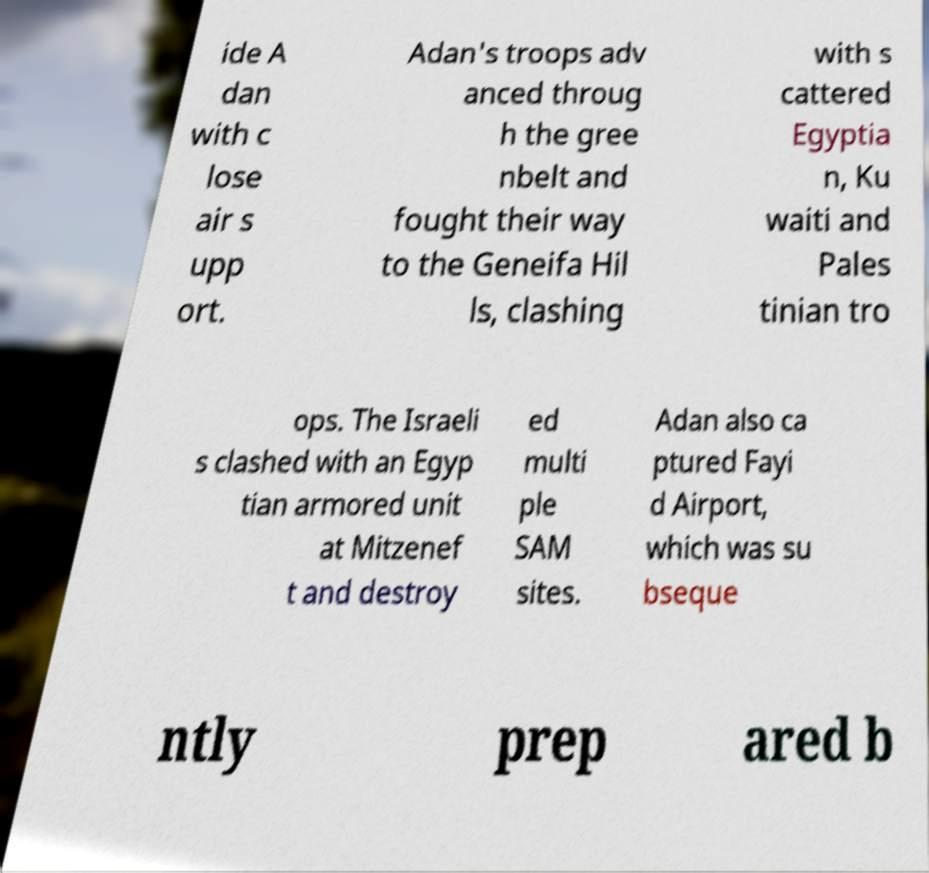Can you read and provide the text displayed in the image?This photo seems to have some interesting text. Can you extract and type it out for me? ide A dan with c lose air s upp ort. Adan's troops adv anced throug h the gree nbelt and fought their way to the Geneifa Hil ls, clashing with s cattered Egyptia n, Ku waiti and Pales tinian tro ops. The Israeli s clashed with an Egyp tian armored unit at Mitzenef t and destroy ed multi ple SAM sites. Adan also ca ptured Fayi d Airport, which was su bseque ntly prep ared b 